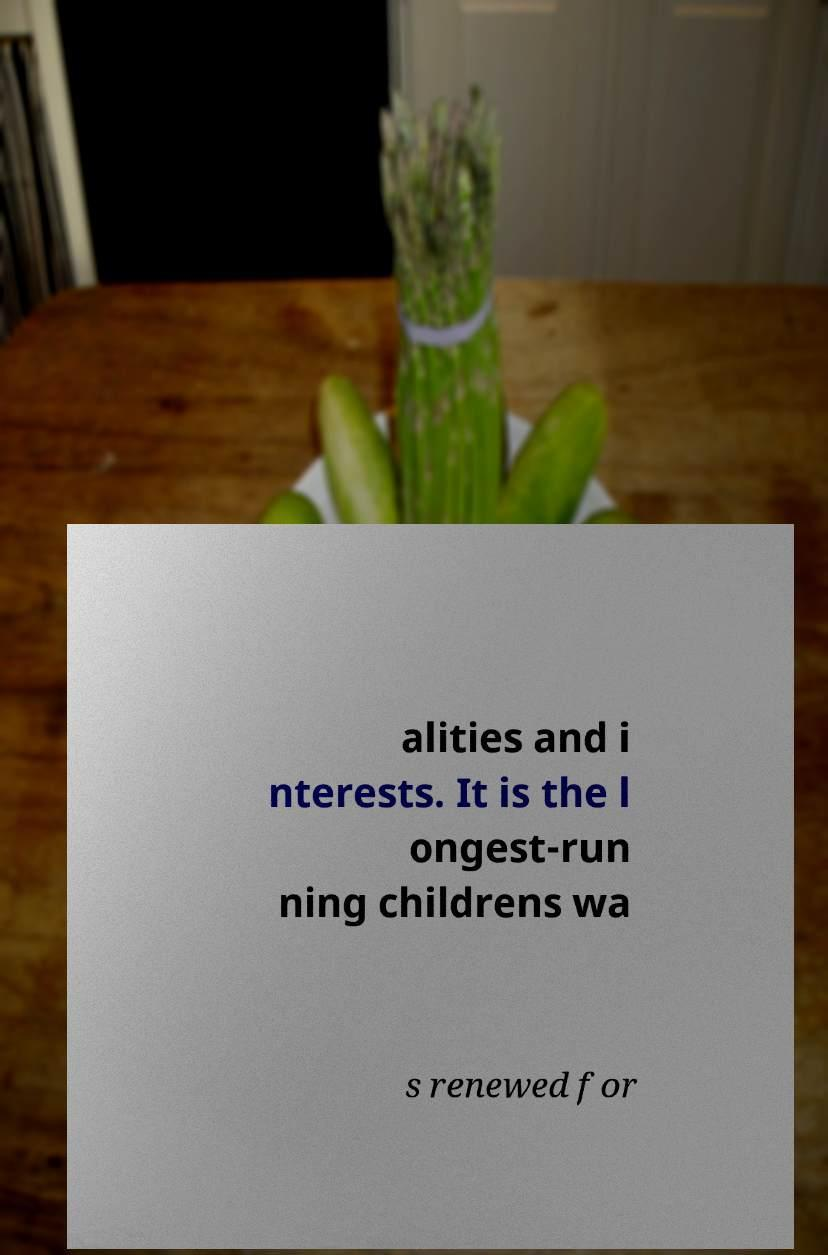Can you accurately transcribe the text from the provided image for me? alities and i nterests. It is the l ongest-run ning childrens wa s renewed for 